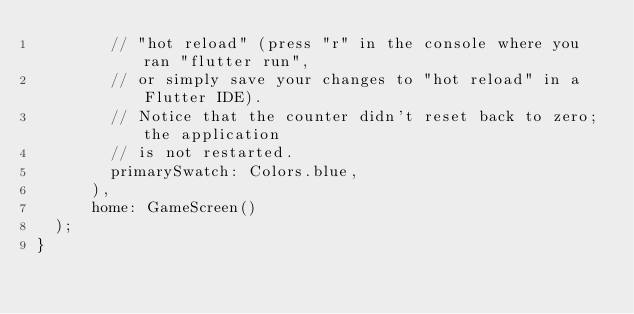Convert code to text. <code><loc_0><loc_0><loc_500><loc_500><_Dart_>        // "hot reload" (press "r" in the console where you ran "flutter run",
        // or simply save your changes to "hot reload" in a Flutter IDE).
        // Notice that the counter didn't reset back to zero; the application
        // is not restarted.
        primarySwatch: Colors.blue,
      ),
      home: GameScreen()
  );
}
</code> 